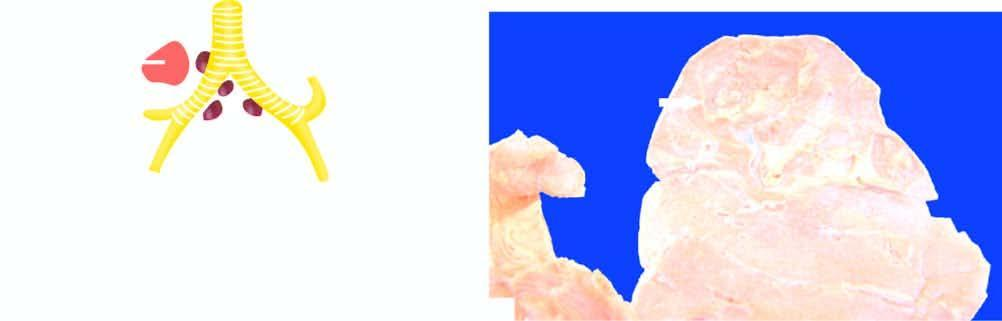s cavitary/open fibrocaseous tuberculos right?
Answer the question using a single word or phrase. Yes 